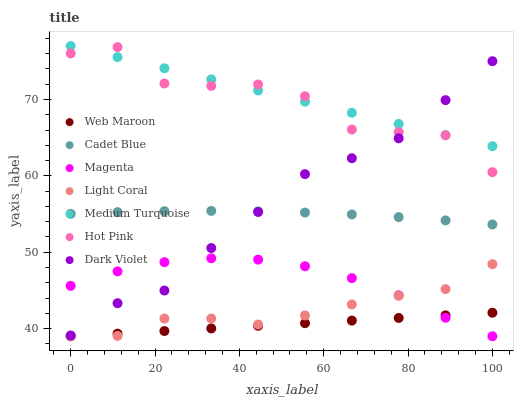Does Web Maroon have the minimum area under the curve?
Answer yes or no. Yes. Does Medium Turquoise have the maximum area under the curve?
Answer yes or no. Yes. Does Hot Pink have the minimum area under the curve?
Answer yes or no. No. Does Hot Pink have the maximum area under the curve?
Answer yes or no. No. Is Medium Turquoise the smoothest?
Answer yes or no. Yes. Is Hot Pink the roughest?
Answer yes or no. Yes. Is Web Maroon the smoothest?
Answer yes or no. No. Is Web Maroon the roughest?
Answer yes or no. No. Does Web Maroon have the lowest value?
Answer yes or no. Yes. Does Hot Pink have the lowest value?
Answer yes or no. No. Does Medium Turquoise have the highest value?
Answer yes or no. Yes. Does Hot Pink have the highest value?
Answer yes or no. No. Is Magenta less than Medium Turquoise?
Answer yes or no. Yes. Is Dark Violet greater than Web Maroon?
Answer yes or no. Yes. Does Web Maroon intersect Magenta?
Answer yes or no. Yes. Is Web Maroon less than Magenta?
Answer yes or no. No. Is Web Maroon greater than Magenta?
Answer yes or no. No. Does Magenta intersect Medium Turquoise?
Answer yes or no. No. 